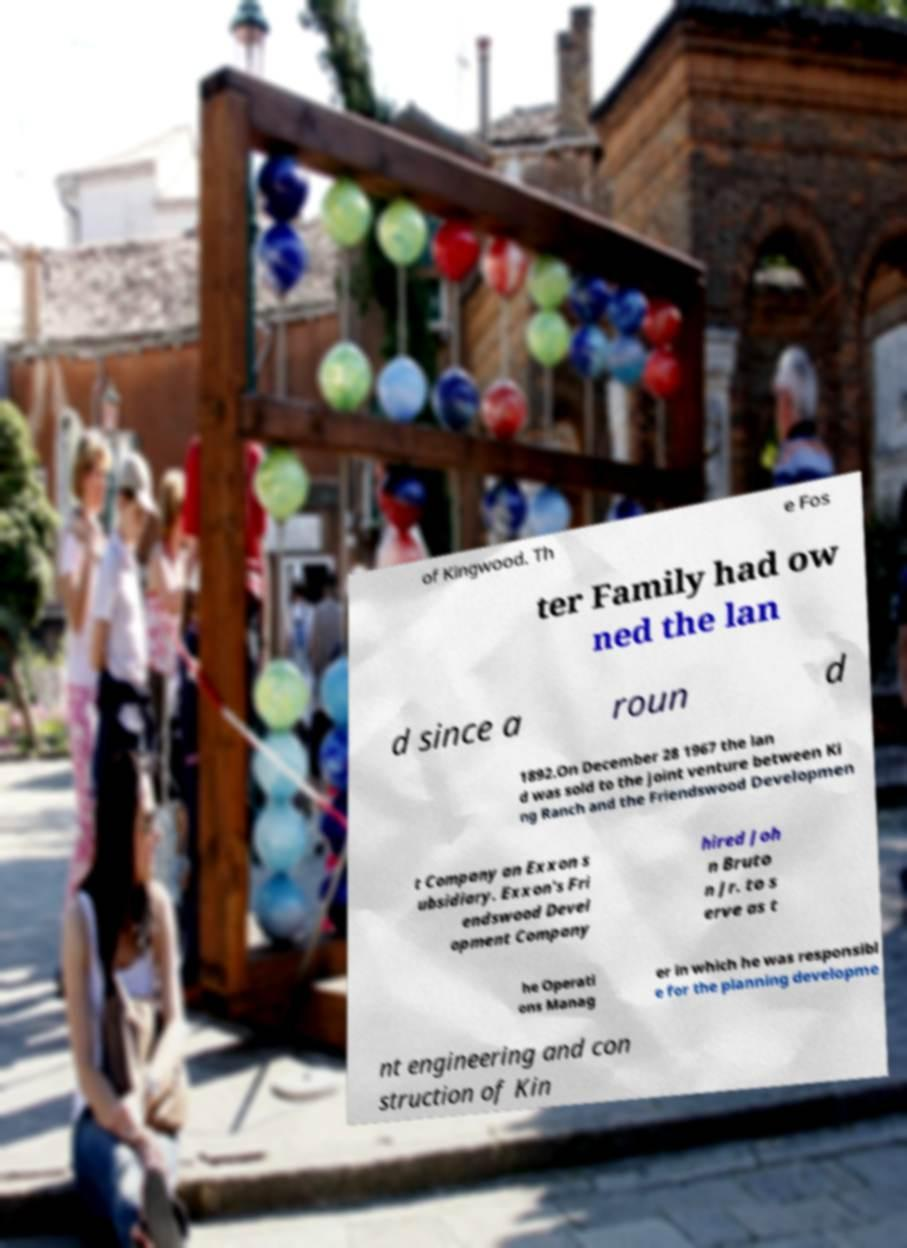Please identify and transcribe the text found in this image. of Kingwood. Th e Fos ter Family had ow ned the lan d since a roun d 1892.On December 28 1967 the lan d was sold to the joint venture between Ki ng Ranch and the Friendswood Developmen t Company an Exxon s ubsidiary. Exxon's Fri endswood Devel opment Company hired Joh n Bruto n Jr. to s erve as t he Operati ons Manag er in which he was responsibl e for the planning developme nt engineering and con struction of Kin 